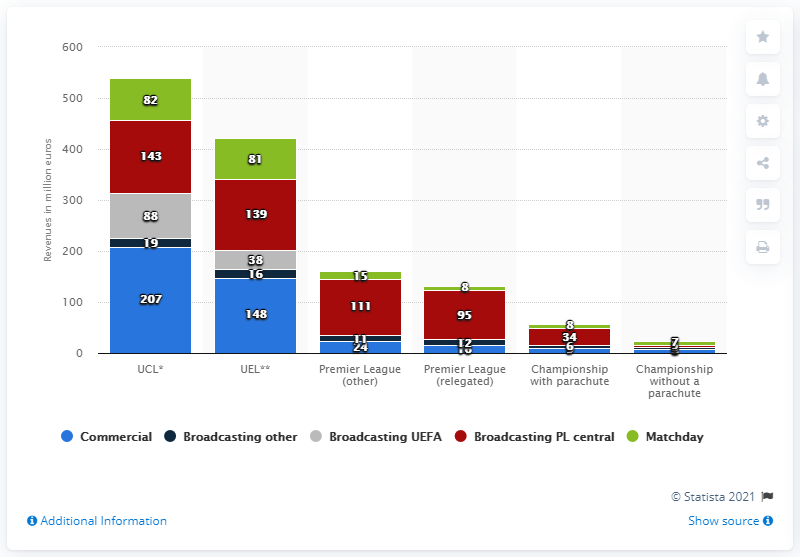Give some essential details in this illustration. The UEFA broadcasting revenue earned by the UCL clubs during the 2018/19 season was approximately 88 million. 